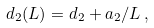<formula> <loc_0><loc_0><loc_500><loc_500>d _ { 2 } ( L ) = d _ { 2 } + a _ { 2 } / L \, ,</formula> 